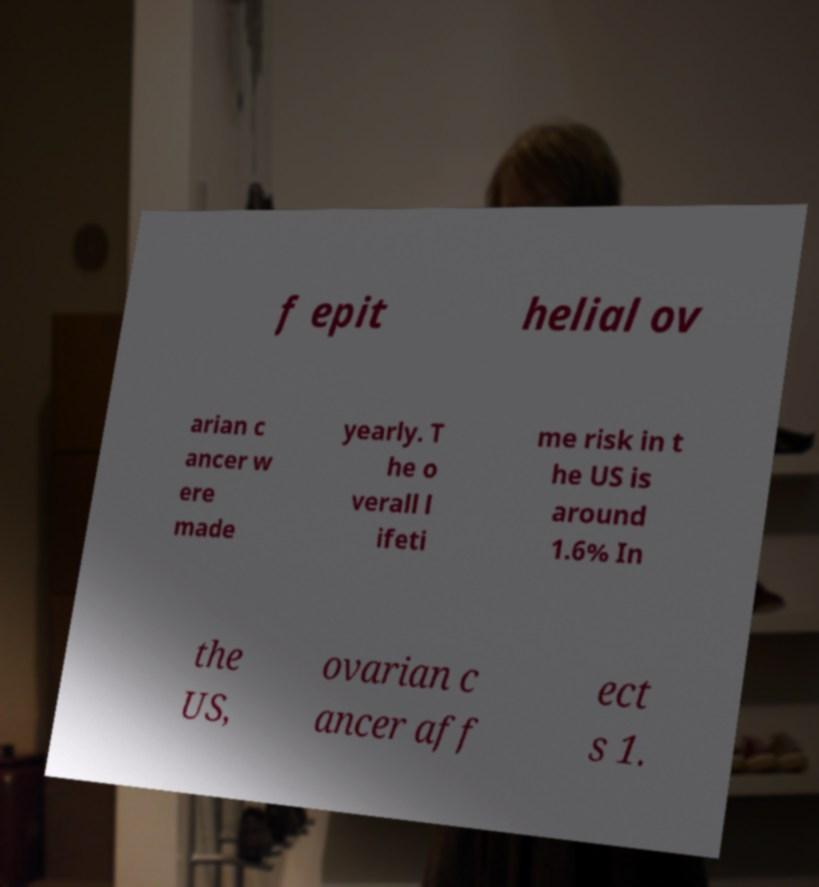I need the written content from this picture converted into text. Can you do that? f epit helial ov arian c ancer w ere made yearly. T he o verall l ifeti me risk in t he US is around 1.6% In the US, ovarian c ancer aff ect s 1. 